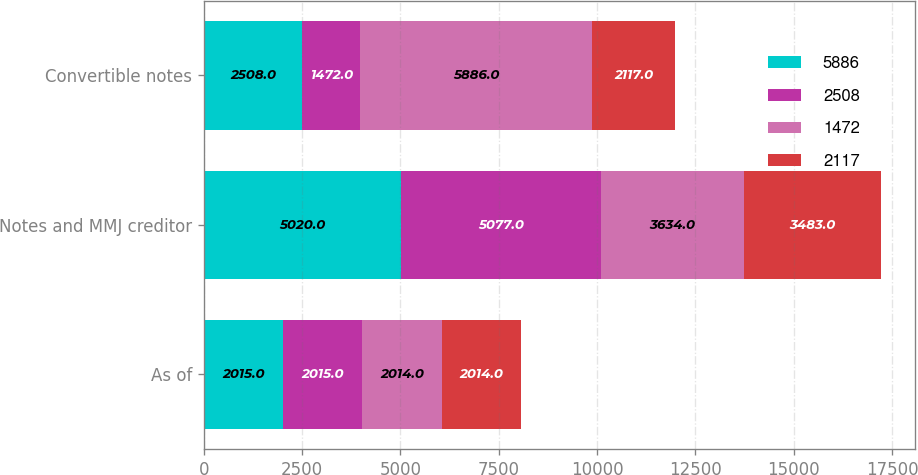<chart> <loc_0><loc_0><loc_500><loc_500><stacked_bar_chart><ecel><fcel>As of<fcel>Notes and MMJ creditor<fcel>Convertible notes<nl><fcel>5886<fcel>2015<fcel>5020<fcel>2508<nl><fcel>2508<fcel>2015<fcel>5077<fcel>1472<nl><fcel>1472<fcel>2014<fcel>3634<fcel>5886<nl><fcel>2117<fcel>2014<fcel>3483<fcel>2117<nl></chart> 